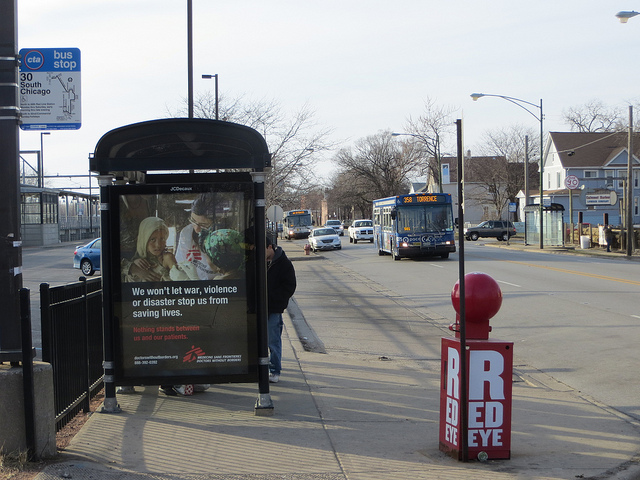<image>In what city is this photo taken? I don't know in what city this photo is taken. It could be Iowa, Akron, Atlanta, Chicago, Los Angeles, or NYC. In what city is this photo taken? I don't know in what city this photo is taken. It can be in Iowa, Akron, Atlanta, Chicago, Los Angeles, NYC, or somewhere else. 